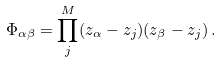Convert formula to latex. <formula><loc_0><loc_0><loc_500><loc_500>\Phi _ { \alpha \beta } = \prod _ { j } ^ { M } ( z _ { \alpha } - z _ { j } ) ( z _ { \beta } - z _ { j } ) \, .</formula> 